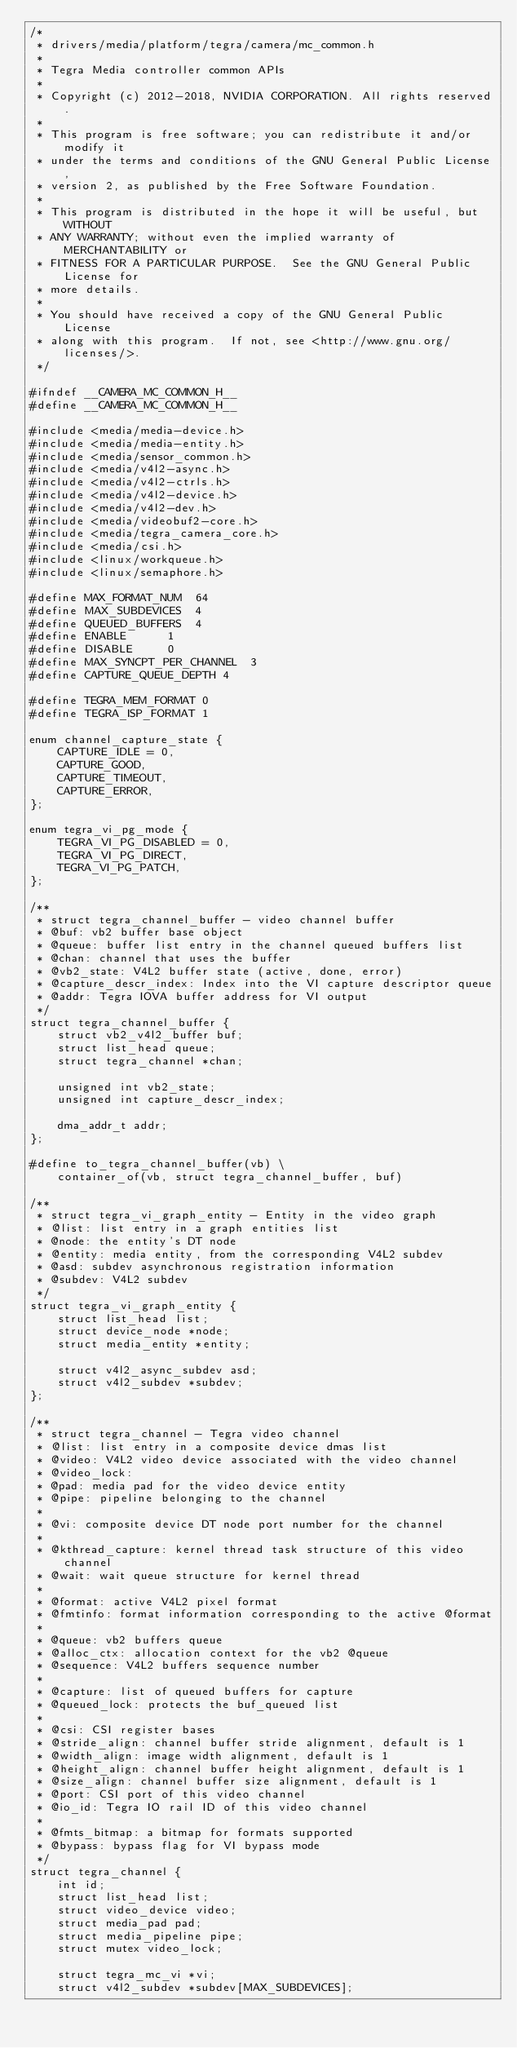Convert code to text. <code><loc_0><loc_0><loc_500><loc_500><_C_>/*
 * drivers/media/platform/tegra/camera/mc_common.h
 *
 * Tegra Media controller common APIs
 *
 * Copyright (c) 2012-2018, NVIDIA CORPORATION. All rights reserved.
 *
 * This program is free software; you can redistribute it and/or modify it
 * under the terms and conditions of the GNU General Public License,
 * version 2, as published by the Free Software Foundation.
 *
 * This program is distributed in the hope it will be useful, but WITHOUT
 * ANY WARRANTY; without even the implied warranty of MERCHANTABILITY or
 * FITNESS FOR A PARTICULAR PURPOSE.  See the GNU General Public License for
 * more details.
 *
 * You should have received a copy of the GNU General Public License
 * along with this program.  If not, see <http://www.gnu.org/licenses/>.
 */

#ifndef __CAMERA_MC_COMMON_H__
#define __CAMERA_MC_COMMON_H__

#include <media/media-device.h>
#include <media/media-entity.h>
#include <media/sensor_common.h>
#include <media/v4l2-async.h>
#include <media/v4l2-ctrls.h>
#include <media/v4l2-device.h>
#include <media/v4l2-dev.h>
#include <media/videobuf2-core.h>
#include <media/tegra_camera_core.h>
#include <media/csi.h>
#include <linux/workqueue.h>
#include <linux/semaphore.h>

#define MAX_FORMAT_NUM	64
#define	MAX_SUBDEVICES	4
#define	QUEUED_BUFFERS	4
#define	ENABLE		1
#define	DISABLE		0
#define MAX_SYNCPT_PER_CHANNEL	3
#define CAPTURE_QUEUE_DEPTH	4

#define TEGRA_MEM_FORMAT 0
#define TEGRA_ISP_FORMAT 1

enum channel_capture_state {
	CAPTURE_IDLE = 0,
	CAPTURE_GOOD,
	CAPTURE_TIMEOUT,
	CAPTURE_ERROR,
};

enum tegra_vi_pg_mode {
	TEGRA_VI_PG_DISABLED = 0,
	TEGRA_VI_PG_DIRECT,
	TEGRA_VI_PG_PATCH,
};

/**
 * struct tegra_channel_buffer - video channel buffer
 * @buf: vb2 buffer base object
 * @queue: buffer list entry in the channel queued buffers list
 * @chan: channel that uses the buffer
 * @vb2_state: V4L2 buffer state (active, done, error)
 * @capture_descr_index: Index into the VI capture descriptor queue
 * @addr: Tegra IOVA buffer address for VI output
 */
struct tegra_channel_buffer {
	struct vb2_v4l2_buffer buf;
	struct list_head queue;
	struct tegra_channel *chan;

	unsigned int vb2_state;
	unsigned int capture_descr_index;

	dma_addr_t addr;
};

#define to_tegra_channel_buffer(vb) \
	container_of(vb, struct tegra_channel_buffer, buf)

/**
 * struct tegra_vi_graph_entity - Entity in the video graph
 * @list: list entry in a graph entities list
 * @node: the entity's DT node
 * @entity: media entity, from the corresponding V4L2 subdev
 * @asd: subdev asynchronous registration information
 * @subdev: V4L2 subdev
 */
struct tegra_vi_graph_entity {
	struct list_head list;
	struct device_node *node;
	struct media_entity *entity;

	struct v4l2_async_subdev asd;
	struct v4l2_subdev *subdev;
};

/**
 * struct tegra_channel - Tegra video channel
 * @list: list entry in a composite device dmas list
 * @video: V4L2 video device associated with the video channel
 * @video_lock:
 * @pad: media pad for the video device entity
 * @pipe: pipeline belonging to the channel
 *
 * @vi: composite device DT node port number for the channel
 *
 * @kthread_capture: kernel thread task structure of this video channel
 * @wait: wait queue structure for kernel thread
 *
 * @format: active V4L2 pixel format
 * @fmtinfo: format information corresponding to the active @format
 *
 * @queue: vb2 buffers queue
 * @alloc_ctx: allocation context for the vb2 @queue
 * @sequence: V4L2 buffers sequence number
 *
 * @capture: list of queued buffers for capture
 * @queued_lock: protects the buf_queued list
 *
 * @csi: CSI register bases
 * @stride_align: channel buffer stride alignment, default is 1
 * @width_align: image width alignment, default is 1
 * @height_align: channel buffer height alignment, default is 1
 * @size_align: channel buffer size alignment, default is 1
 * @port: CSI port of this video channel
 * @io_id: Tegra IO rail ID of this video channel
 *
 * @fmts_bitmap: a bitmap for formats supported
 * @bypass: bypass flag for VI bypass mode
 */
struct tegra_channel {
	int id;
	struct list_head list;
	struct video_device video;
	struct media_pad pad;
	struct media_pipeline pipe;
	struct mutex video_lock;

	struct tegra_mc_vi *vi;
	struct v4l2_subdev *subdev[MAX_SUBDEVICES];</code> 